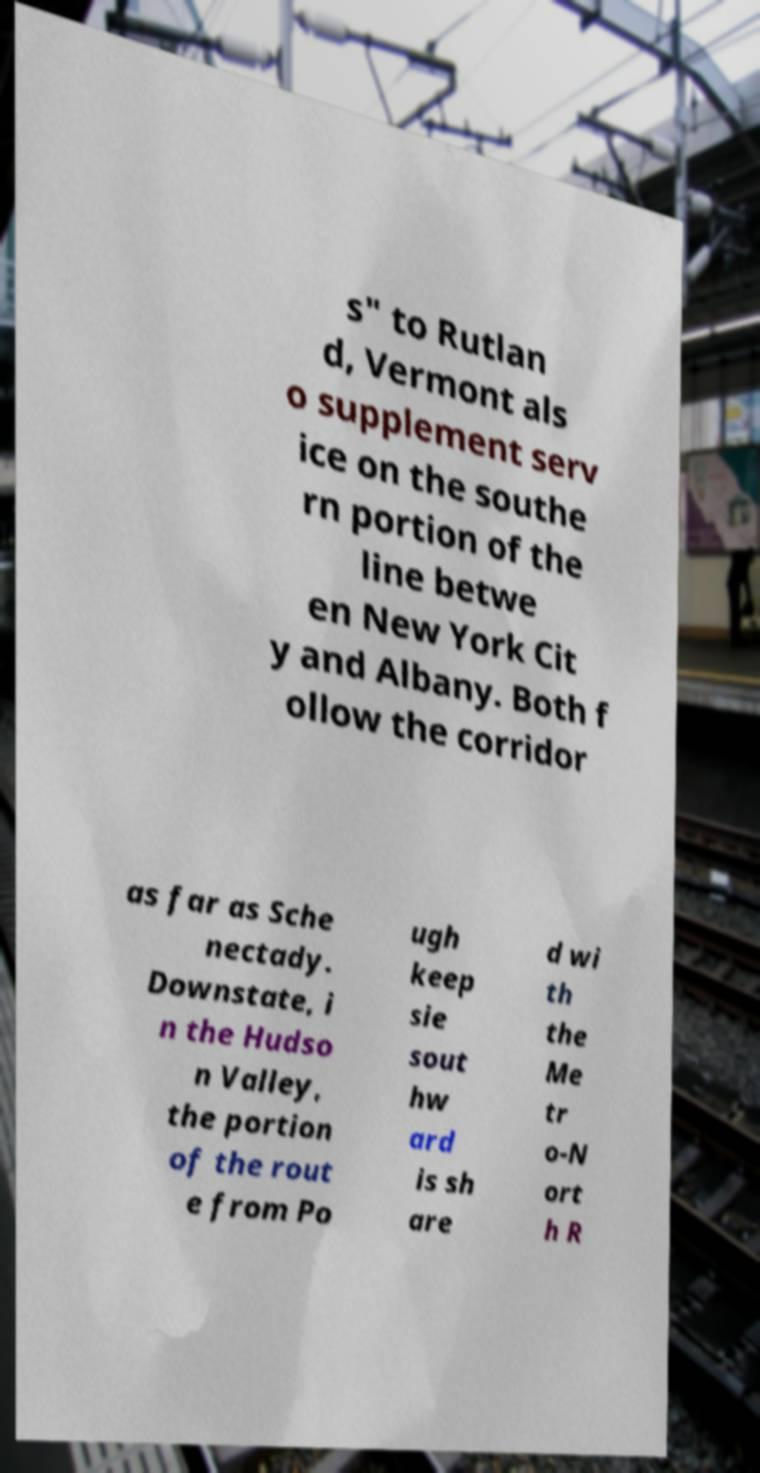Could you extract and type out the text from this image? s" to Rutlan d, Vermont als o supplement serv ice on the southe rn portion of the line betwe en New York Cit y and Albany. Both f ollow the corridor as far as Sche nectady. Downstate, i n the Hudso n Valley, the portion of the rout e from Po ugh keep sie sout hw ard is sh are d wi th the Me tr o-N ort h R 